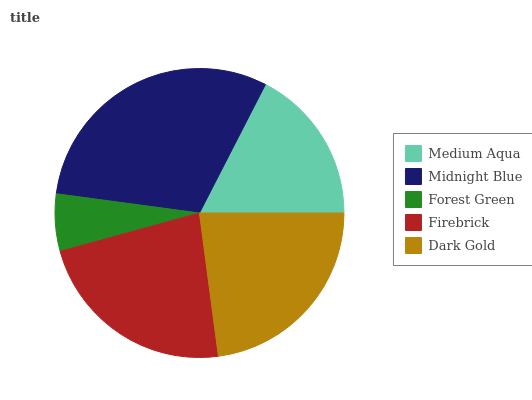Is Forest Green the minimum?
Answer yes or no. Yes. Is Midnight Blue the maximum?
Answer yes or no. Yes. Is Midnight Blue the minimum?
Answer yes or no. No. Is Forest Green the maximum?
Answer yes or no. No. Is Midnight Blue greater than Forest Green?
Answer yes or no. Yes. Is Forest Green less than Midnight Blue?
Answer yes or no. Yes. Is Forest Green greater than Midnight Blue?
Answer yes or no. No. Is Midnight Blue less than Forest Green?
Answer yes or no. No. Is Firebrick the high median?
Answer yes or no. Yes. Is Firebrick the low median?
Answer yes or no. Yes. Is Forest Green the high median?
Answer yes or no. No. Is Forest Green the low median?
Answer yes or no. No. 